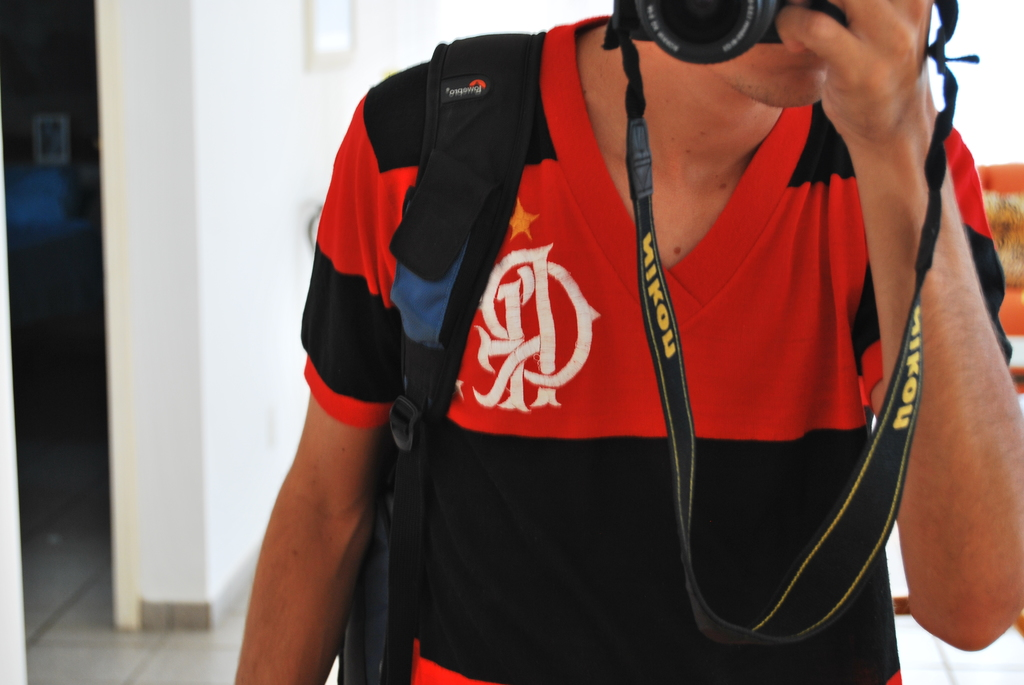Describe the setting shown in the background of the image. The background shows a bright, modern room with white walls and a hint of furniture, suggesting a domestic or perhaps a professional setting tailored for comfort and simplicity. 